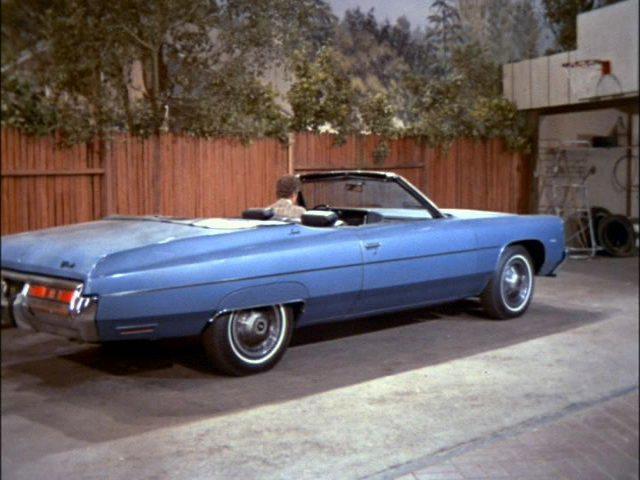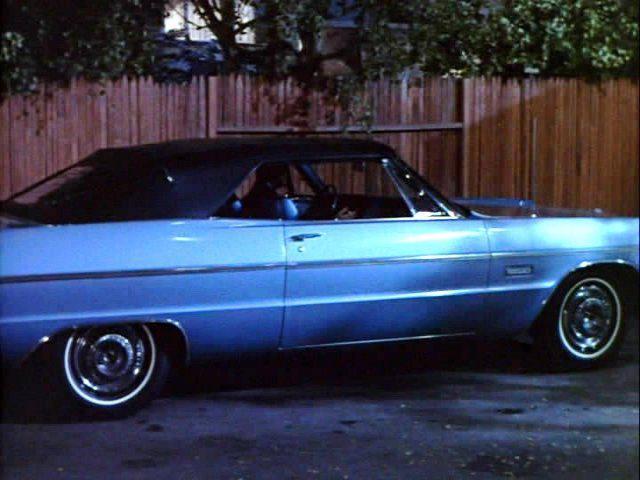The first image is the image on the left, the second image is the image on the right. Considering the images on both sides, is "A young fellow bends and touches the front of a beat-up looking dark blue convertiblee." valid? Answer yes or no. No. The first image is the image on the left, the second image is the image on the right. Given the left and right images, does the statement "There is exactly one car in the right image that is parked beside a wooden fence." hold true? Answer yes or no. Yes. 